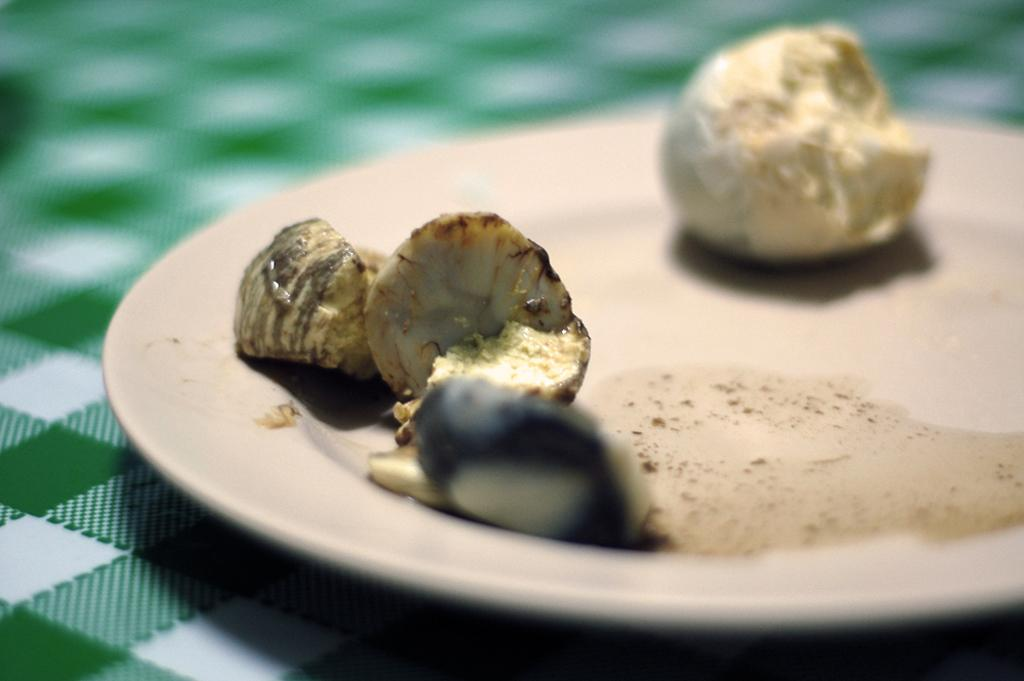What piece of furniture is present in the image? There is a table in the image. What is placed on the table? There is a plate on the table. What can be found on the plate? There is a food item on the plate. What type of yoke is visible in the image? There is no yoke present in the image. What game is being played on the table in the image? There is no game being played in the image; it only shows a table, a plate, and a food item on the plate. 